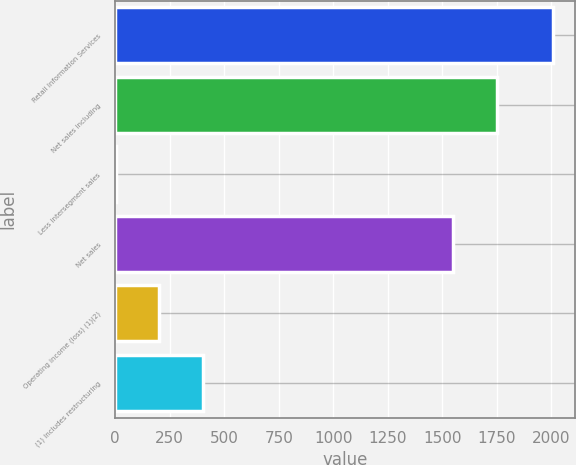Convert chart. <chart><loc_0><loc_0><loc_500><loc_500><bar_chart><fcel>Retail Information Services<fcel>Net sales including<fcel>Less intersegment sales<fcel>Net sales<fcel>Operating income (loss) (1)(2)<fcel>(1) Includes restructuring<nl><fcel>2008<fcel>1749.29<fcel>2.1<fcel>1548.7<fcel>202.69<fcel>403.28<nl></chart> 